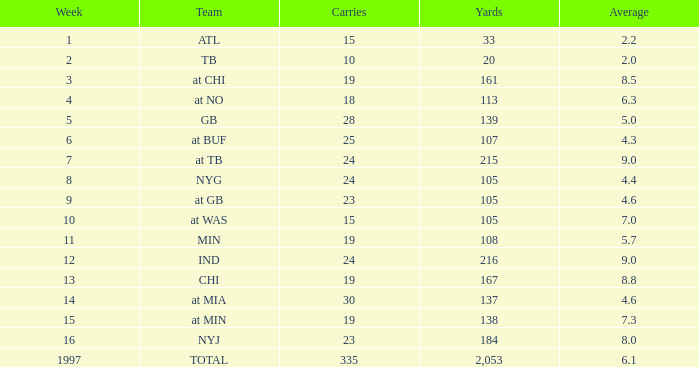Which Team has 19 Carries, and a Week larger than 13? At min. 